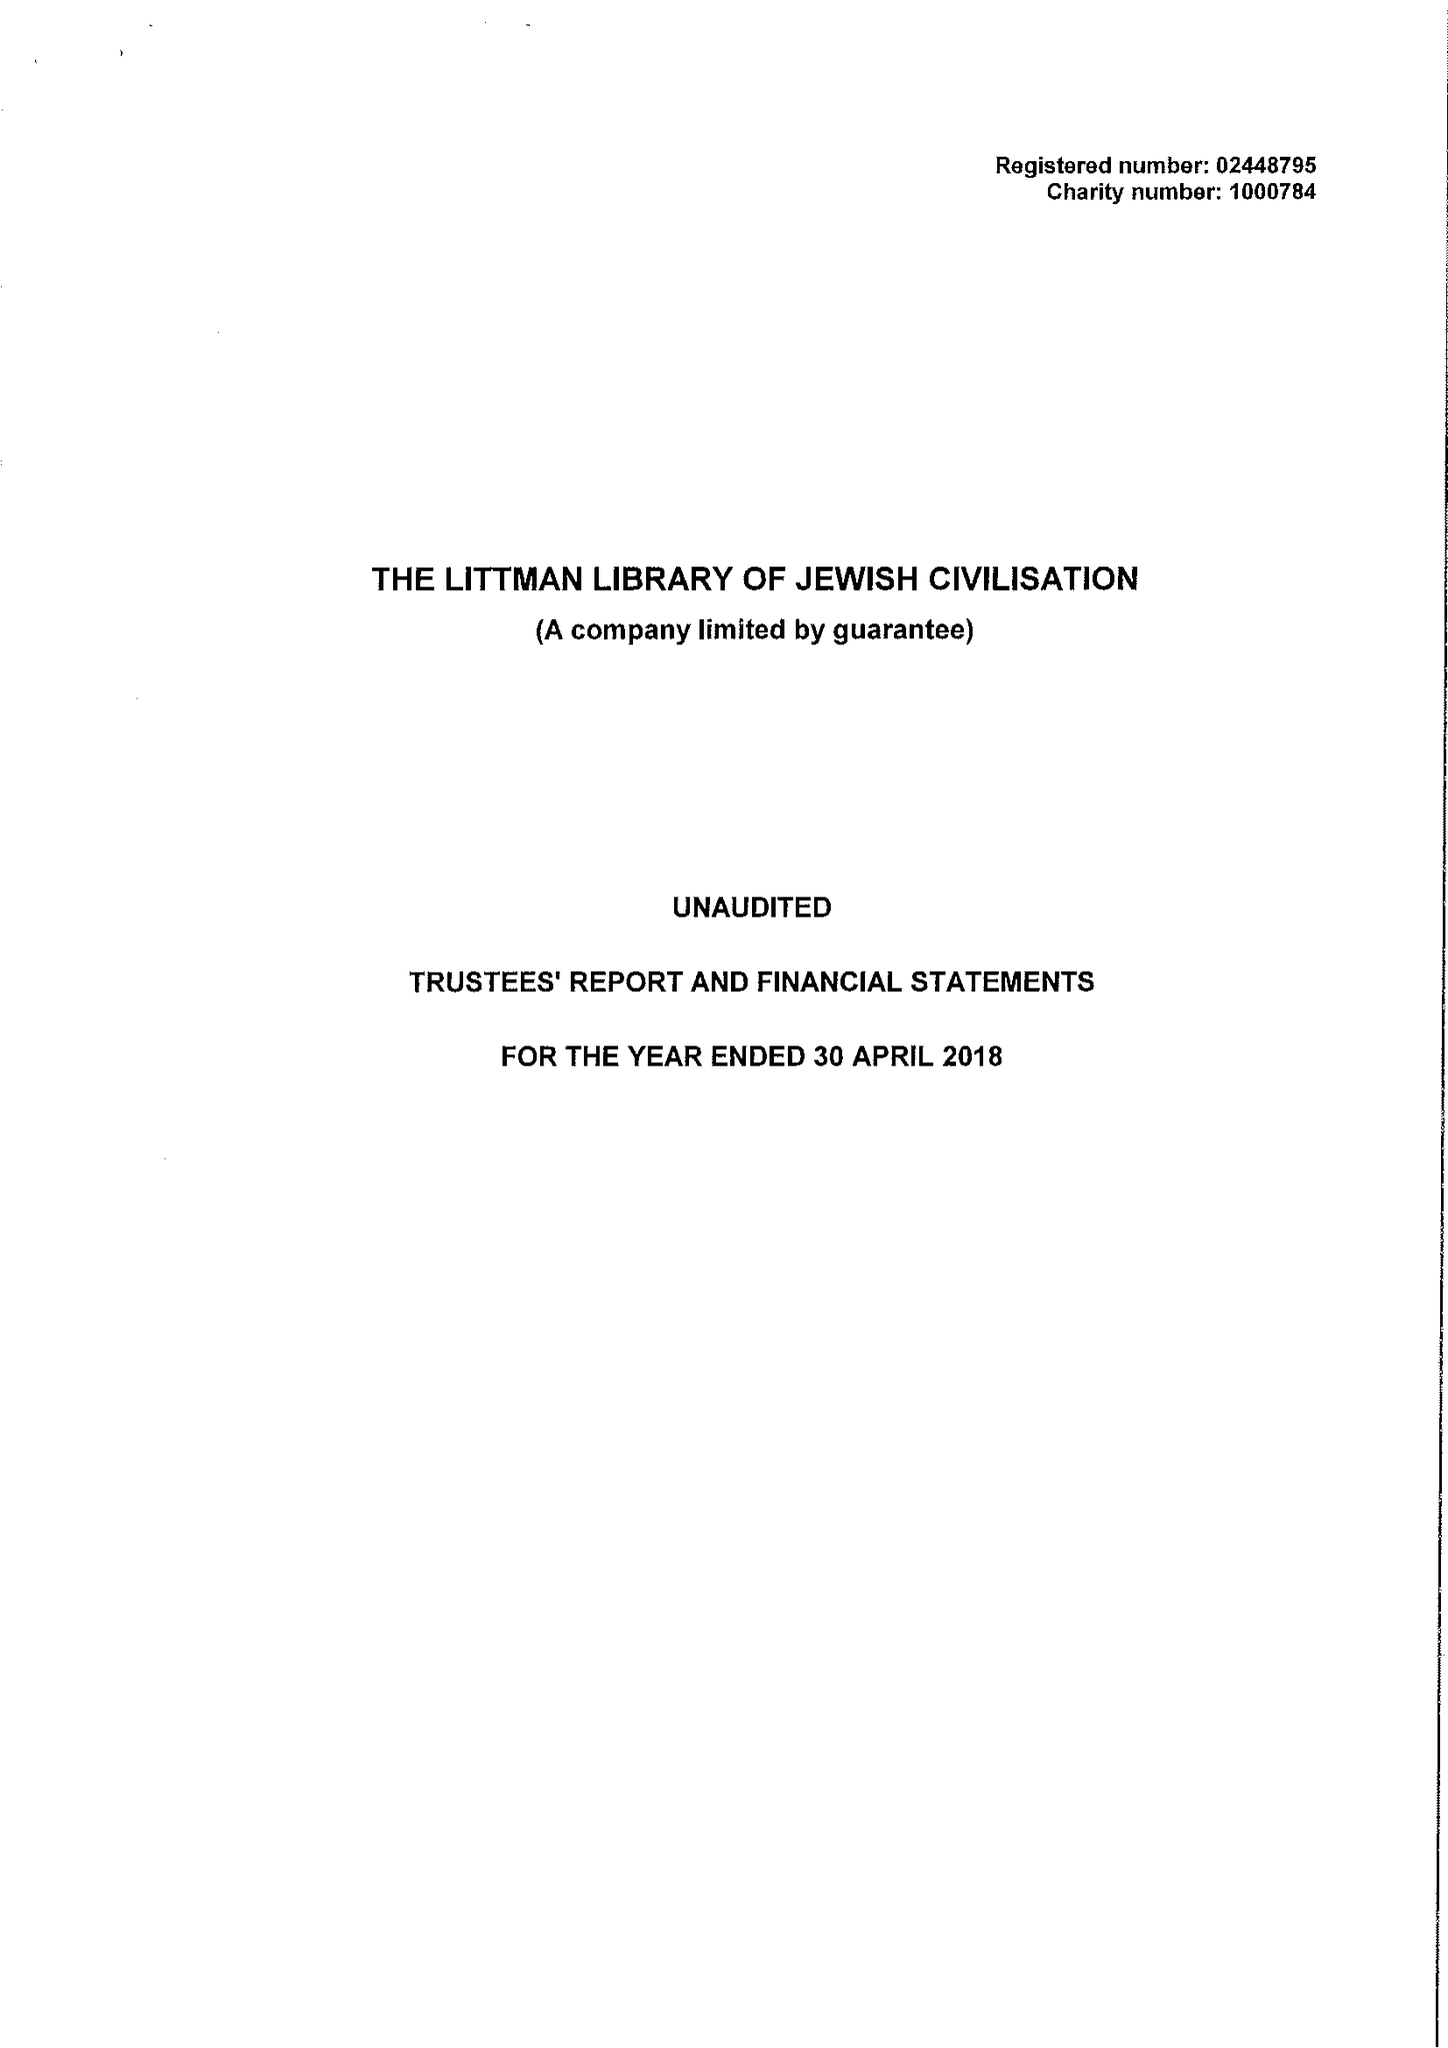What is the value for the address__post_town?
Answer the question using a single word or phrase. SOMERTON 